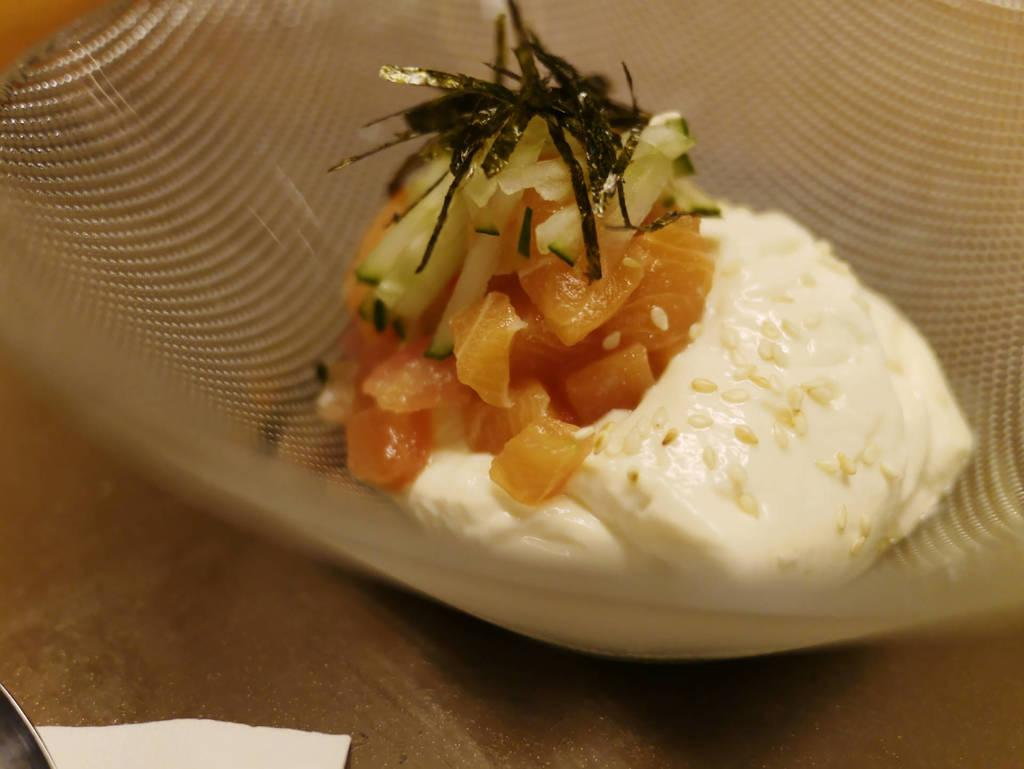What is the main subject of the image? The main subject of the image is food. How is the food presented in the image? The food is in a bowl. What type of punishment is being served in the bowl in the image? There is no punishment present in the image; it features food in a bowl. How does the food relate to the person's self in the image? There is no person present in the image, so it cannot be determined how the food relates to their self. 